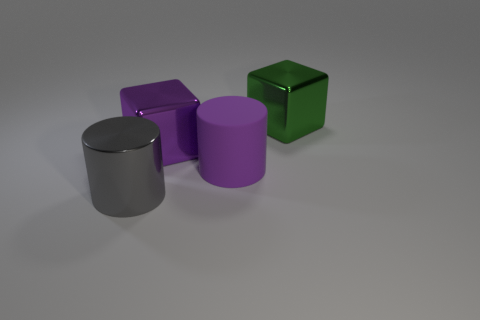Does the big purple block have the same material as the big cylinder on the left side of the large purple cylinder?
Your response must be concise. Yes. Is the number of large purple metallic cubes in front of the large gray cylinder less than the number of big green objects that are in front of the purple matte object?
Keep it short and to the point. No. What is the material of the big cube that is behind the purple metallic cube?
Your answer should be compact. Metal. There is a object that is both behind the purple rubber object and in front of the large green shiny block; what color is it?
Make the answer very short. Purple. How many other objects are the same color as the big rubber thing?
Keep it short and to the point. 1. What is the color of the big block on the left side of the rubber object?
Make the answer very short. Purple. Is there a green object that has the same size as the gray metal thing?
Provide a succinct answer. Yes. What material is the purple thing that is the same size as the purple matte cylinder?
Your answer should be very brief. Metal. How many things are blocks left of the large green cube or large metal cubes on the left side of the big green metallic object?
Your answer should be compact. 1. Are there any other large metal things that have the same shape as the large purple metal thing?
Provide a succinct answer. Yes. 